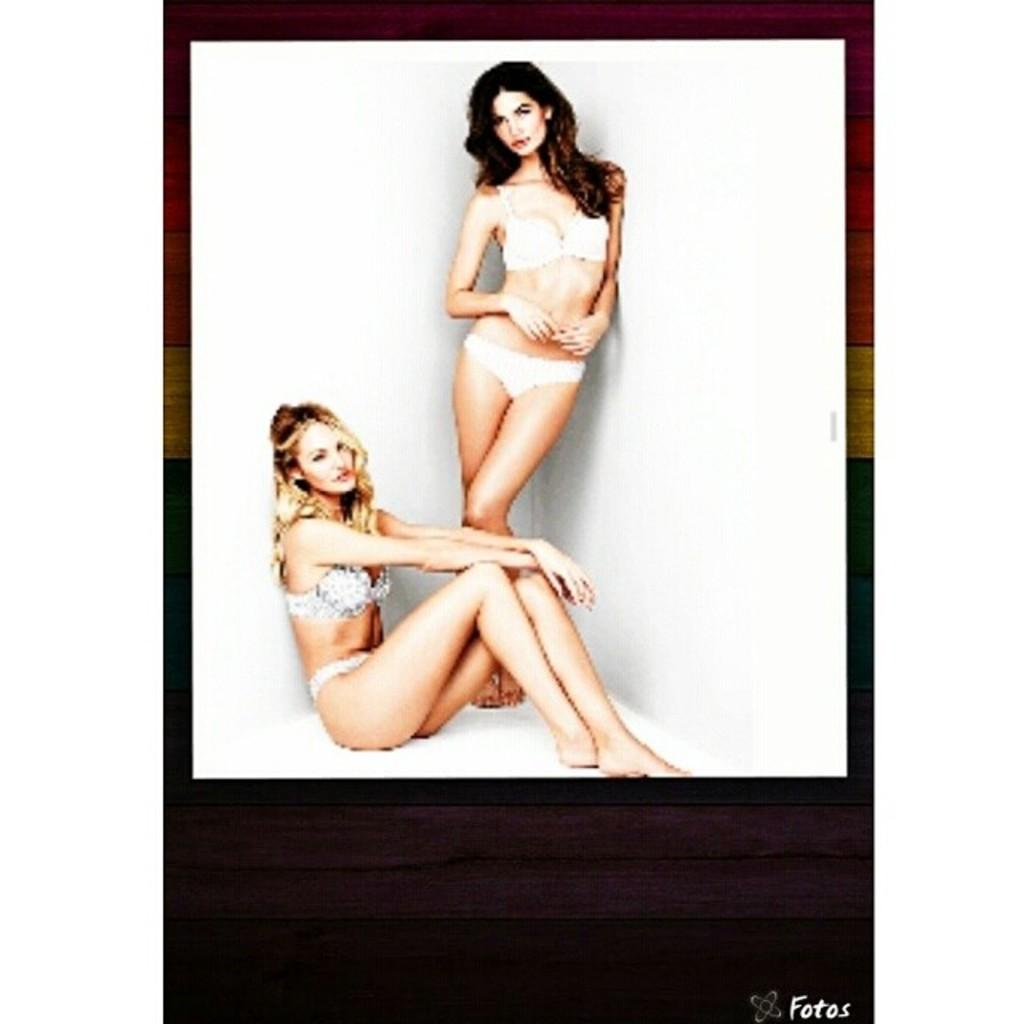How many people are in the image? There are two women in the image. What can be seen on the wall in the image? There is a white color wall in the image. What date is marked on the calendar in the image? There is no calendar present in the image. What type of heart is visible in the image? There is no heart present in the image. 